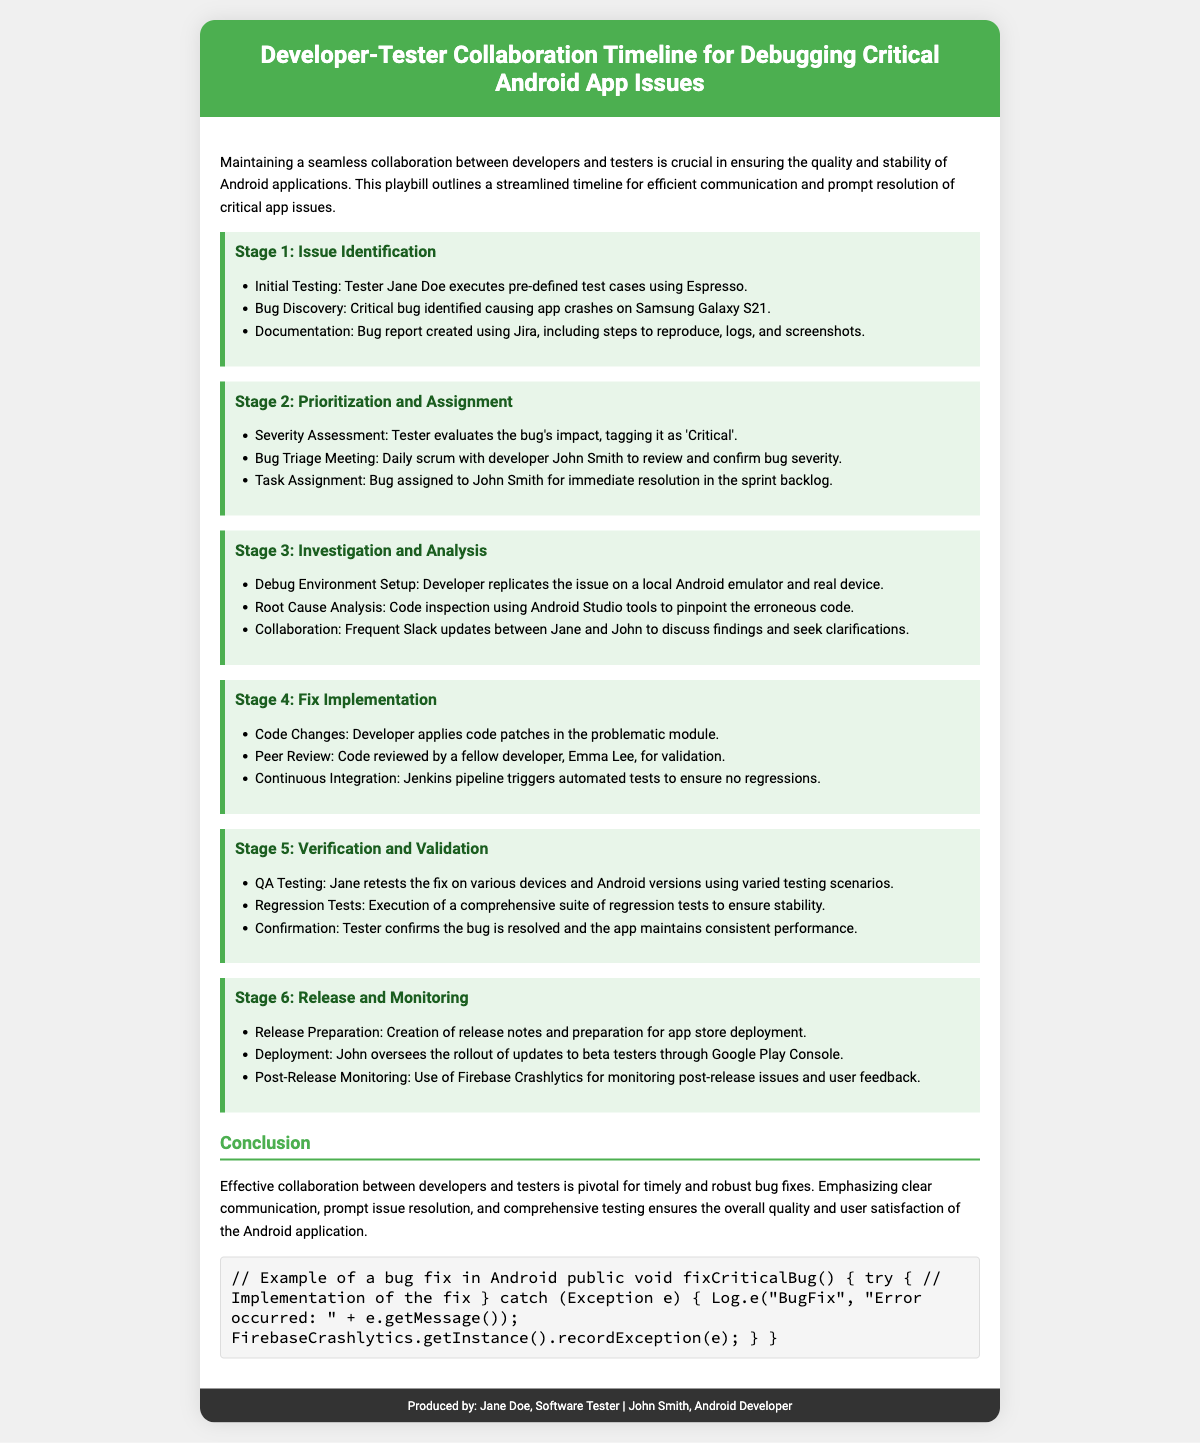What is the first stage of the timeline? The first stage outlined in the document is focused on issue identification, detailing the initial testing and bug discovery process.
Answer: Issue Identification Who is the developer assigned to fix the critical bug? The document designates John Smith as the developer responsible for addressing the identified critical bug.
Answer: John Smith What tool is used for bug documentation? The document specifies that Jira is used for creating the bug report, which includes necessary details about the bug.
Answer: Jira What is the severity status of the bug? The severity of the bug is assessed by the tester, who tags it as 'Critical' during the assessment section of the timeline.
Answer: Critical Which tool is mentioned for post-release monitoring? Firebase Crashlytics is highlighted in the document as the tool used for monitoring issues and gathering user feedback after release.
Answer: Firebase Crashlytics How many stages are described in the timeline? The timeline includes a total of six distinct stages that outline the collaboration process between developers and testers for debugging.
Answer: Six In what environment did the developer replicate the issue? The developer replicated the bug in both a local Android emulator and a real device, as stated during the investigation and analysis stage.
Answer: Local Android emulator and real device What is the focus of the conclusion section? The conclusion emphasizes the importance of effective collaboration between developers and testers for timely and robust bug fixes.
Answer: Effective collaboration What brief coding example is included in the document? The document includes an example of a bug fix implemented in Android, highlighting error handling and logging.
Answer: Implementation of the fix 